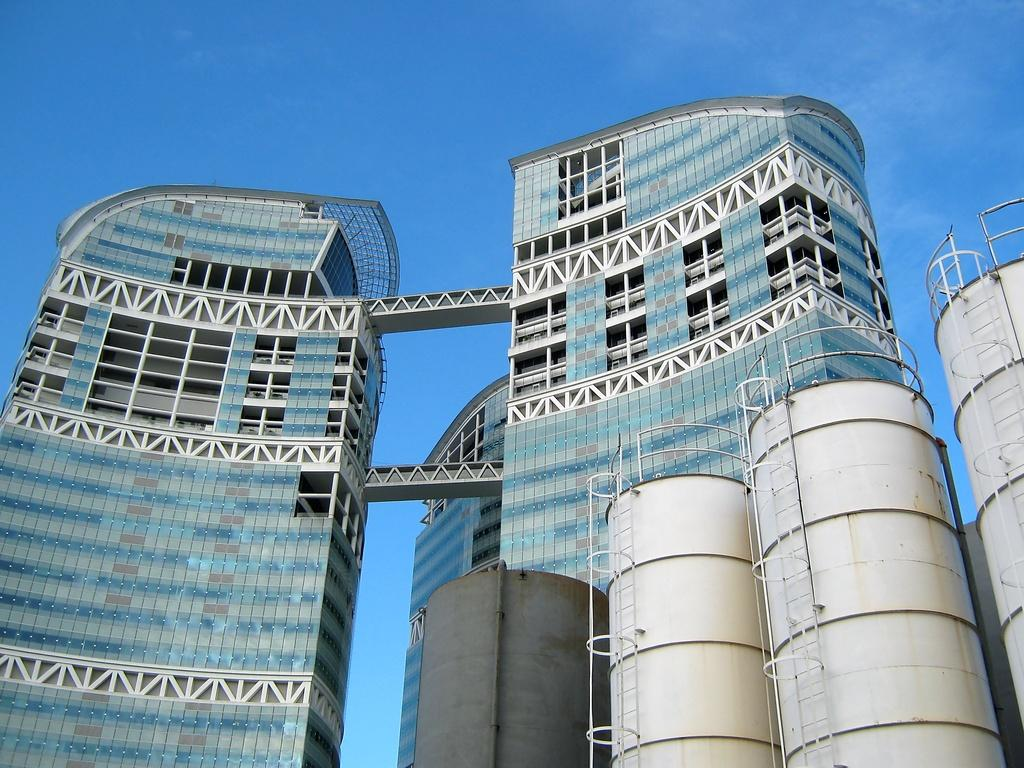What type of building is in the image? There is a skyscraper in the image. What objects can be seen at the bottom left of the image? There are steel round barrels at the bottom left of the image. What is visible at the top of the image? The sky is visible at the top of the image. What can be observed in the sky? Clouds are present in the sky. How many boys are kicking the crate in the image? There are no boys or crates present in the image. 